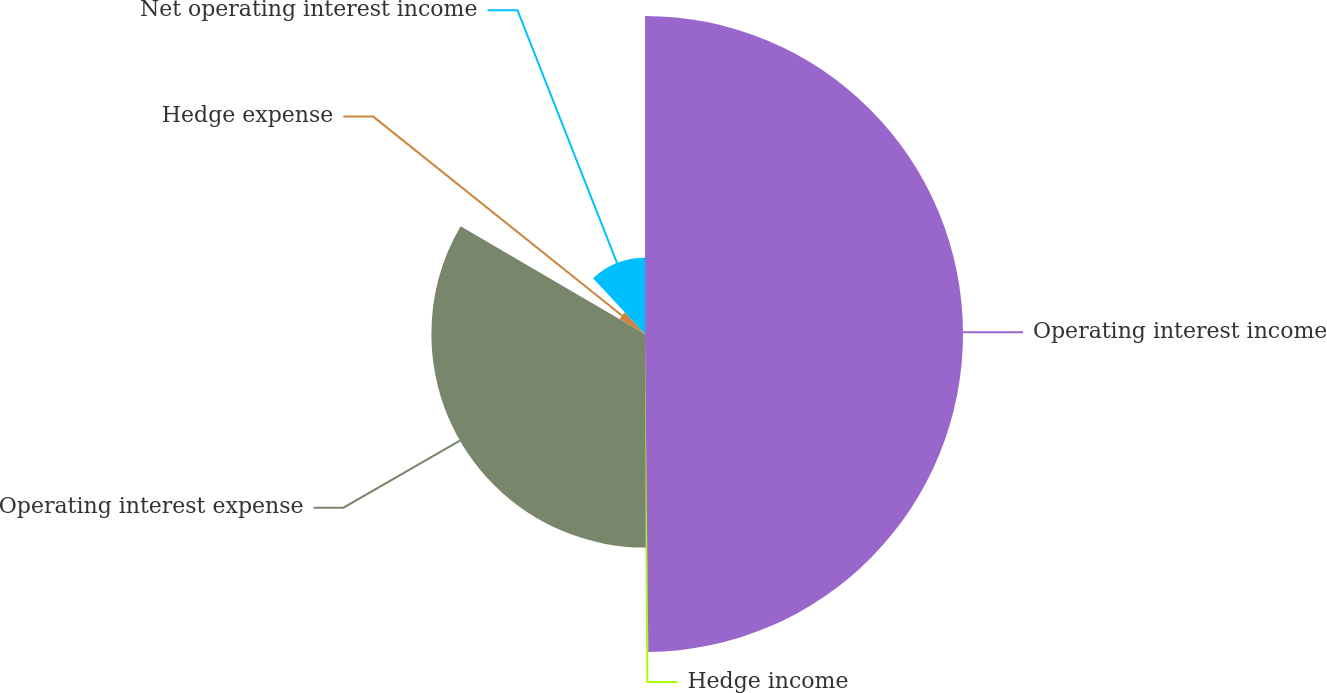<chart> <loc_0><loc_0><loc_500><loc_500><pie_chart><fcel>Operating interest income<fcel>Hedge income<fcel>Operating interest expense<fcel>Hedge expense<fcel>Net operating interest income<nl><fcel>49.83%<fcel>0.11%<fcel>33.47%<fcel>4.64%<fcel>11.94%<nl></chart> 